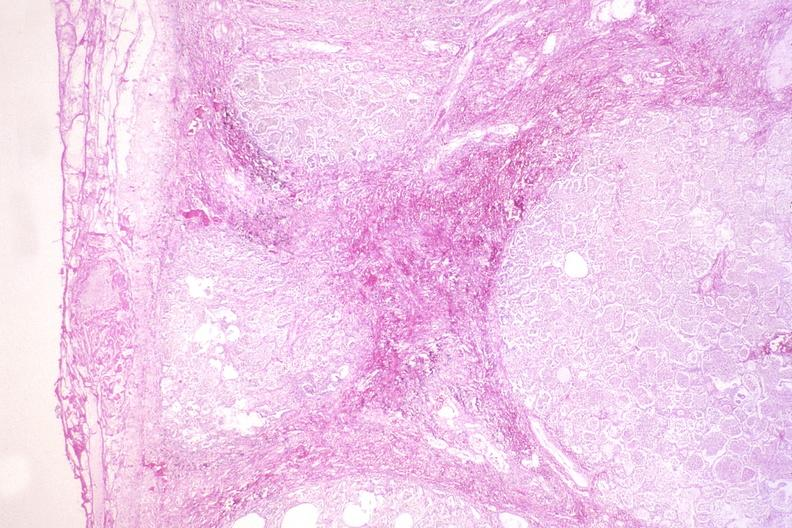s gangrene present?
Answer the question using a single word or phrase. No 